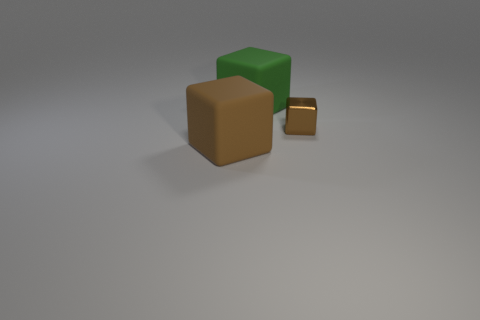Add 2 small red rubber cylinders. How many objects exist? 5 Subtract 0 gray cylinders. How many objects are left? 3 Subtract all rubber objects. Subtract all tiny brown metallic things. How many objects are left? 0 Add 1 metal things. How many metal things are left? 2 Add 3 big yellow metal objects. How many big yellow metal objects exist? 3 